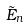<formula> <loc_0><loc_0><loc_500><loc_500>\tilde { E } _ { n }</formula> 